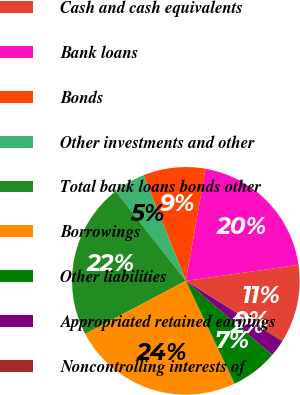Convert chart. <chart><loc_0><loc_0><loc_500><loc_500><pie_chart><fcel>Cash and cash equivalents<fcel>Bank loans<fcel>Bonds<fcel>Other investments and other<fcel>Total bank loans bonds other<fcel>Borrowings<fcel>Other liabilities<fcel>Appropriated retained earnings<fcel>Noncontrolling interests of<nl><fcel>10.98%<fcel>20.0%<fcel>8.83%<fcel>4.51%<fcel>22.16%<fcel>24.32%<fcel>6.67%<fcel>2.35%<fcel>0.19%<nl></chart> 